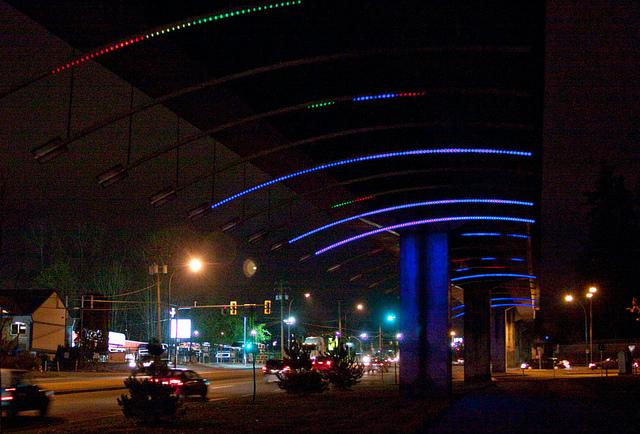The area underneath the structure is illuminated by what?

Choices:
A) fluorescent lights
B) hps lights
C) led lights
D) incandescent lights led lights 